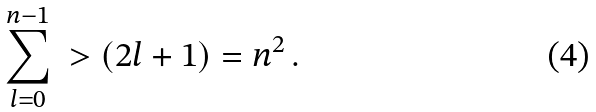<formula> <loc_0><loc_0><loc_500><loc_500>\sum _ { l = 0 } ^ { n - 1 } \ > ( 2 l + 1 ) = n ^ { 2 } \, .</formula> 